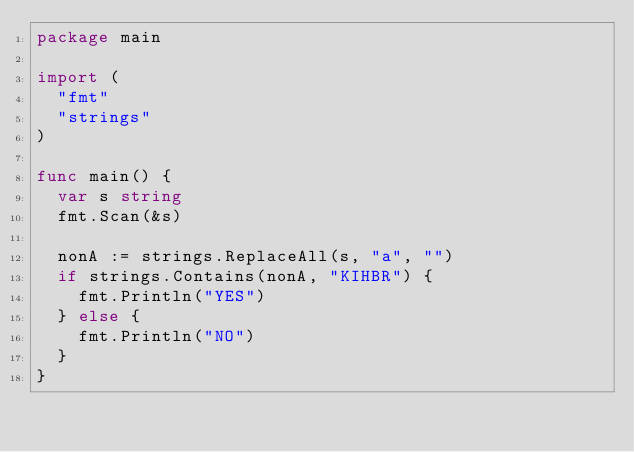Convert code to text. <code><loc_0><loc_0><loc_500><loc_500><_Go_>package main

import (
	"fmt"
	"strings"
)

func main() {
	var s string
	fmt.Scan(&s)

	nonA := strings.ReplaceAll(s, "a", "")
	if strings.Contains(nonA, "KIHBR") {
		fmt.Println("YES")
	} else {
		fmt.Println("NO")
	}
}
</code> 